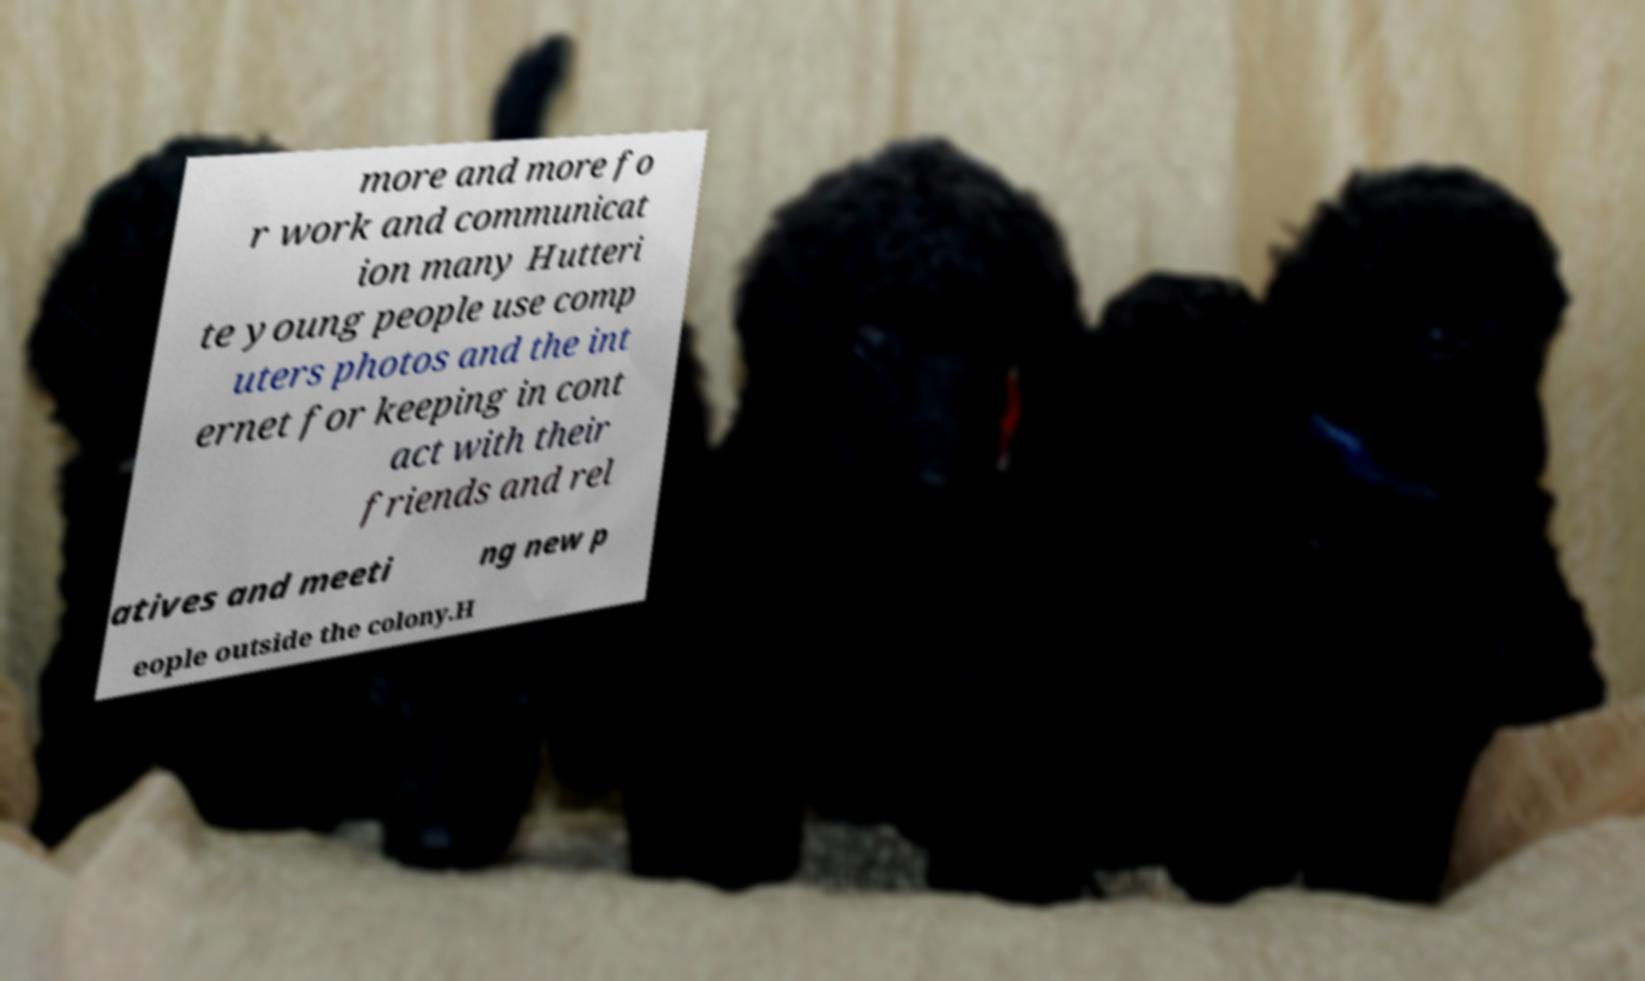Can you accurately transcribe the text from the provided image for me? more and more fo r work and communicat ion many Hutteri te young people use comp uters photos and the int ernet for keeping in cont act with their friends and rel atives and meeti ng new p eople outside the colony.H 